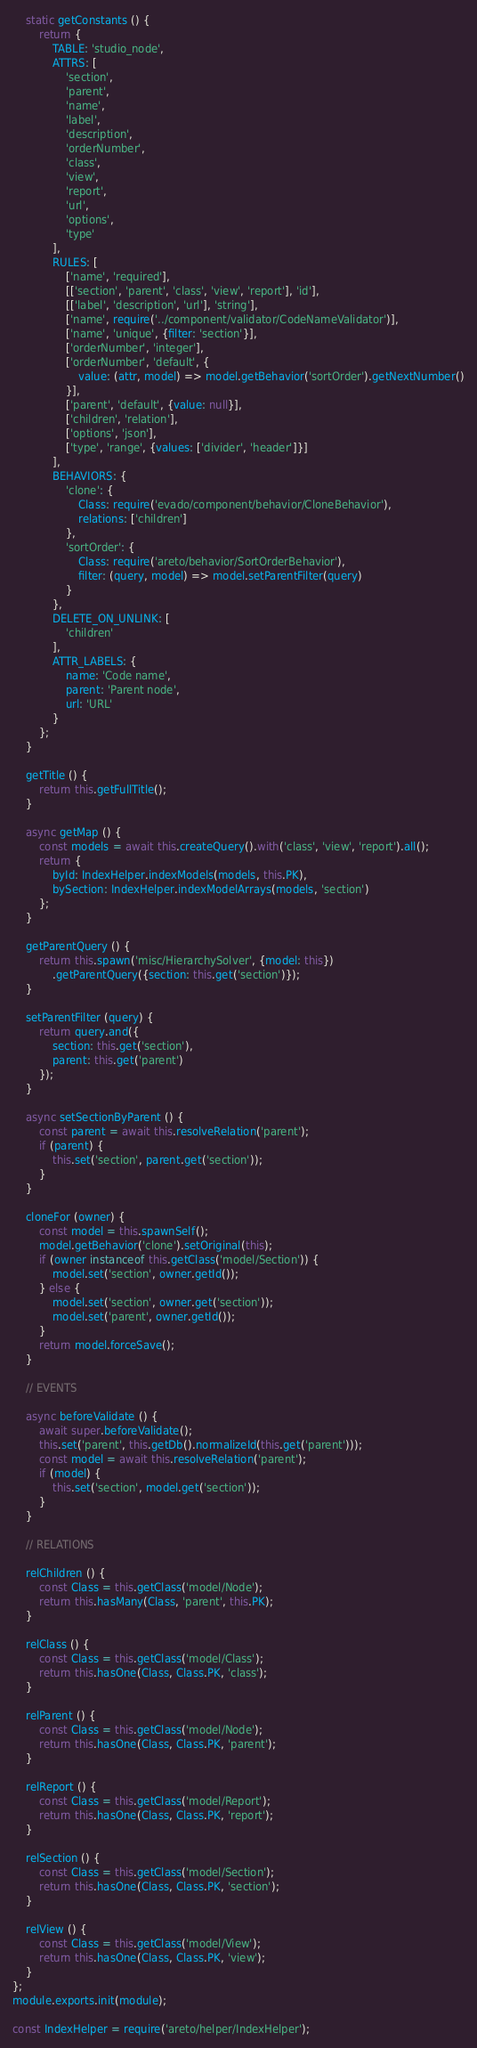<code> <loc_0><loc_0><loc_500><loc_500><_JavaScript_>
    static getConstants () {
        return {
            TABLE: 'studio_node',
            ATTRS: [
                'section',
                'parent',
                'name',
                'label',
                'description',
                'orderNumber',
                'class',
                'view',
                'report',
                'url',
                'options',
                'type'
            ],
            RULES: [
                ['name', 'required'],
                [['section', 'parent', 'class', 'view', 'report'], 'id'],
                [['label', 'description', 'url'], 'string'],
                ['name', require('../component/validator/CodeNameValidator')],
                ['name', 'unique', {filter: 'section'}],
                ['orderNumber', 'integer'],
                ['orderNumber', 'default', {
                    value: (attr, model) => model.getBehavior('sortOrder').getNextNumber()
                }],
                ['parent', 'default', {value: null}],
                ['children', 'relation'],
                ['options', 'json'],
                ['type', 'range', {values: ['divider', 'header']}]
            ],
            BEHAVIORS: {
                'clone': {
                    Class: require('evado/component/behavior/CloneBehavior'),
                    relations: ['children']
                },
                'sortOrder': {
                    Class: require('areto/behavior/SortOrderBehavior'),
                    filter: (query, model) => model.setParentFilter(query)
                }
            },
            DELETE_ON_UNLINK: [
                'children'
            ],
            ATTR_LABELS: {
                name: 'Code name',
                parent: 'Parent node',
                url: 'URL'
            }
        };
    }

    getTitle () {
        return this.getFullTitle();
    }

    async getMap () {
        const models = await this.createQuery().with('class', 'view', 'report').all();
        return {
            byId: IndexHelper.indexModels(models, this.PK),
            bySection: IndexHelper.indexModelArrays(models, 'section')
        };
    }

    getParentQuery () {
        return this.spawn('misc/HierarchySolver', {model: this})
            .getParentQuery({section: this.get('section')});
    }

    setParentFilter (query) {
        return query.and({
            section: this.get('section'),
            parent: this.get('parent')
        });
    }

    async setSectionByParent () {
        const parent = await this.resolveRelation('parent');
        if (parent) {
            this.set('section', parent.get('section'));
        }
    }

    cloneFor (owner) {
        const model = this.spawnSelf();
        model.getBehavior('clone').setOriginal(this);
        if (owner instanceof this.getClass('model/Section')) {
            model.set('section', owner.getId());
        } else {
            model.set('section', owner.get('section'));
            model.set('parent', owner.getId());
        }
        return model.forceSave();
    }

    // EVENTS

    async beforeValidate () {
        await super.beforeValidate();
        this.set('parent', this.getDb().normalizeId(this.get('parent')));
        const model = await this.resolveRelation('parent');
        if (model) {
            this.set('section', model.get('section'));
        }
    }

    // RELATIONS

    relChildren () {
        const Class = this.getClass('model/Node');
        return this.hasMany(Class, 'parent', this.PK);
    }

    relClass () {
        const Class = this.getClass('model/Class');
        return this.hasOne(Class, Class.PK, 'class');
    }

    relParent () {
        const Class = this.getClass('model/Node');
        return this.hasOne(Class, Class.PK, 'parent');
    }

    relReport () {
        const Class = this.getClass('model/Report');
        return this.hasOne(Class, Class.PK, 'report');
    }

    relSection () {
        const Class = this.getClass('model/Section');
        return this.hasOne(Class, Class.PK, 'section');
    }

    relView () {
        const Class = this.getClass('model/View');
        return this.hasOne(Class, Class.PK, 'view');
    }
};
module.exports.init(module);

const IndexHelper = require('areto/helper/IndexHelper');</code> 